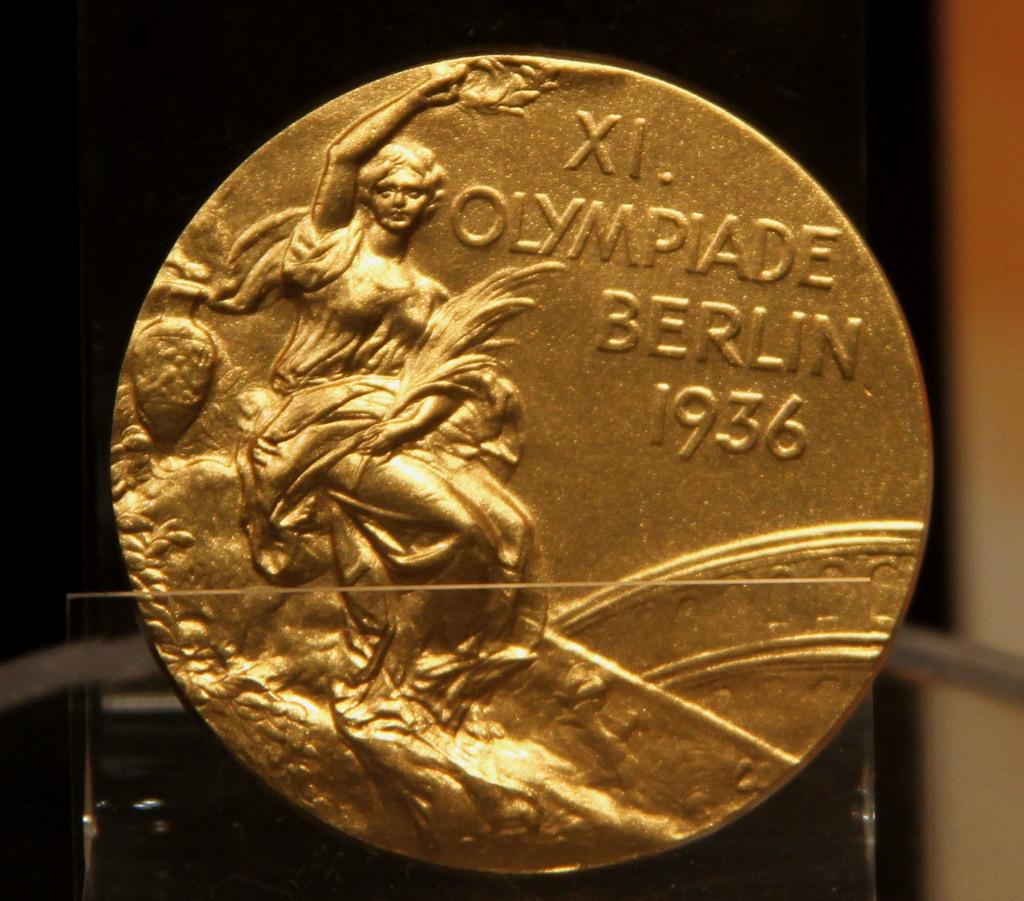Which year was this?
Ensure brevity in your answer.  1936. What's the celebrating?
Ensure brevity in your answer.  Olympiade berlin 1936. 